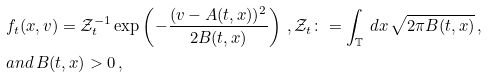<formula> <loc_0><loc_0><loc_500><loc_500>& f _ { t } ( x , v ) = \mathcal { Z } _ { t } ^ { - 1 } \exp \left ( - \frac { ( v - A ( t , x ) ) ^ { 2 } } { 2 B ( t , x ) } \right ) \, , \mathcal { Z } _ { t } \colon = \int _ { \mathbb { T } } \, d x \, \sqrt { 2 \pi B ( t , x ) } \, , \\ & a n d \, B ( t , x ) > 0 \, ,</formula> 